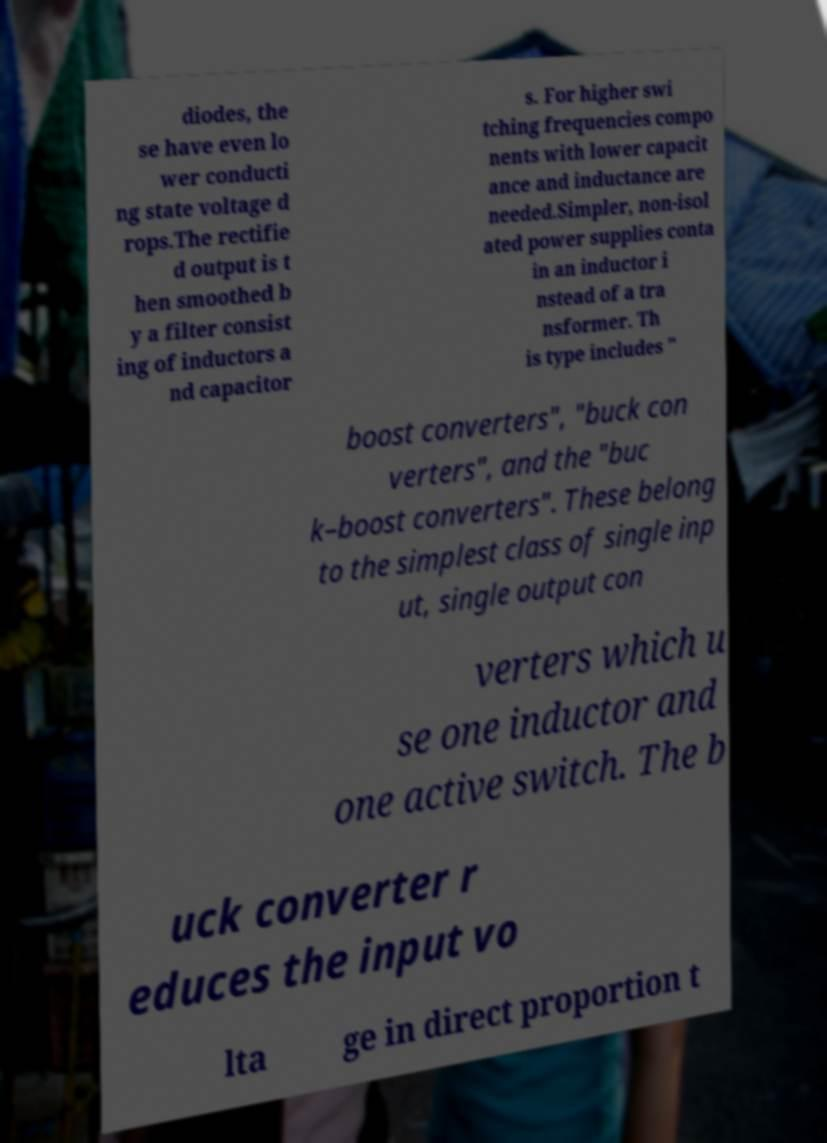Please read and relay the text visible in this image. What does it say? diodes, the se have even lo wer conducti ng state voltage d rops.The rectifie d output is t hen smoothed b y a filter consist ing of inductors a nd capacitor s. For higher swi tching frequencies compo nents with lower capacit ance and inductance are needed.Simpler, non-isol ated power supplies conta in an inductor i nstead of a tra nsformer. Th is type includes " boost converters", "buck con verters", and the "buc k–boost converters". These belong to the simplest class of single inp ut, single output con verters which u se one inductor and one active switch. The b uck converter r educes the input vo lta ge in direct proportion t 